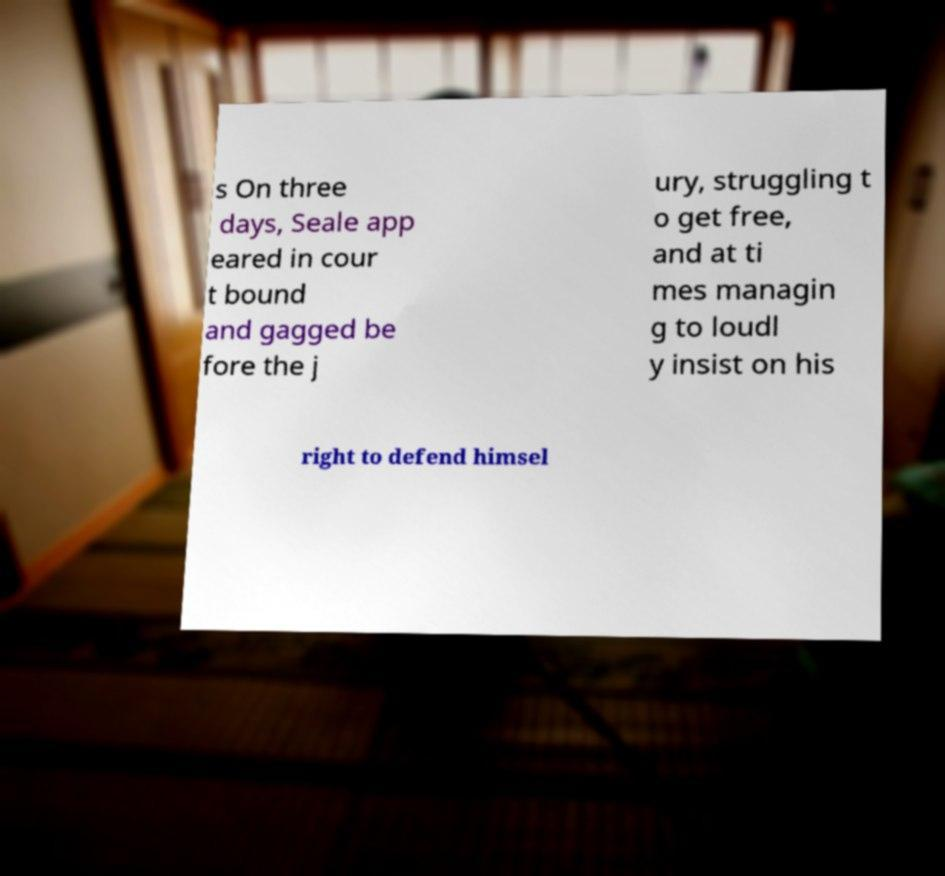Can you read and provide the text displayed in the image?This photo seems to have some interesting text. Can you extract and type it out for me? s On three days, Seale app eared in cour t bound and gagged be fore the j ury, struggling t o get free, and at ti mes managin g to loudl y insist on his right to defend himsel 